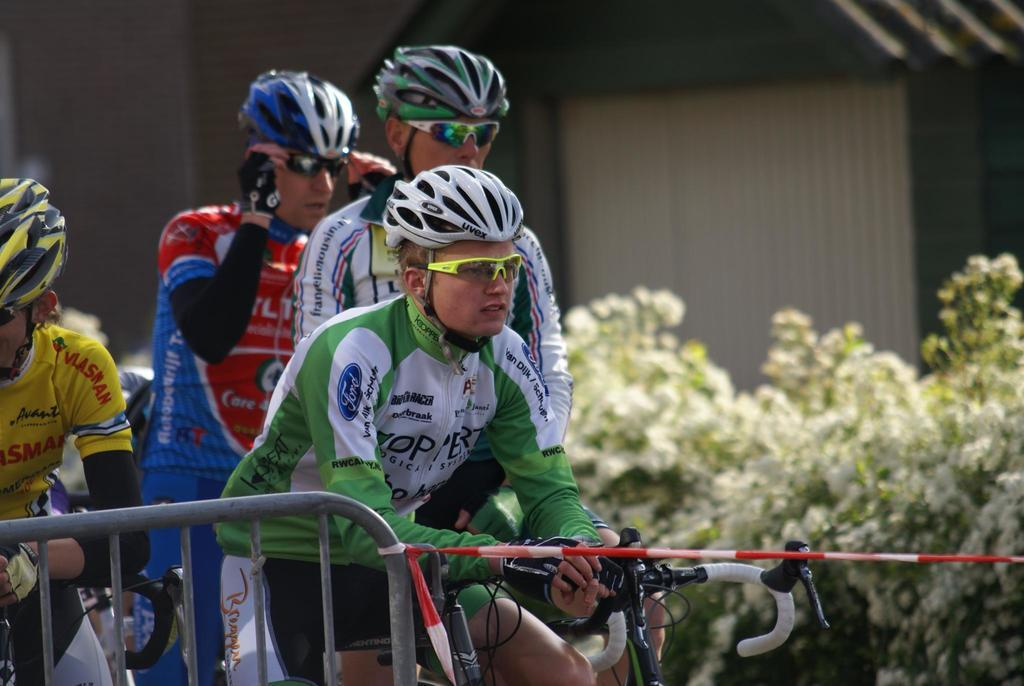What is present in the image that separates or encloses an area? There is a fence in the image. What is attached to the fence? A cloth is tied to the fence. What can be seen in the background of the image? There are four men sitting on bicycles and a wall in the background of the image. What type of vegetation is visible in the background? There are plants in the background of the image. How many turkeys are flying over the men in the image? There are no turkeys present in the image. What type of growth can be seen on the wall in the image? There is no growth visible on the wall in the image. 